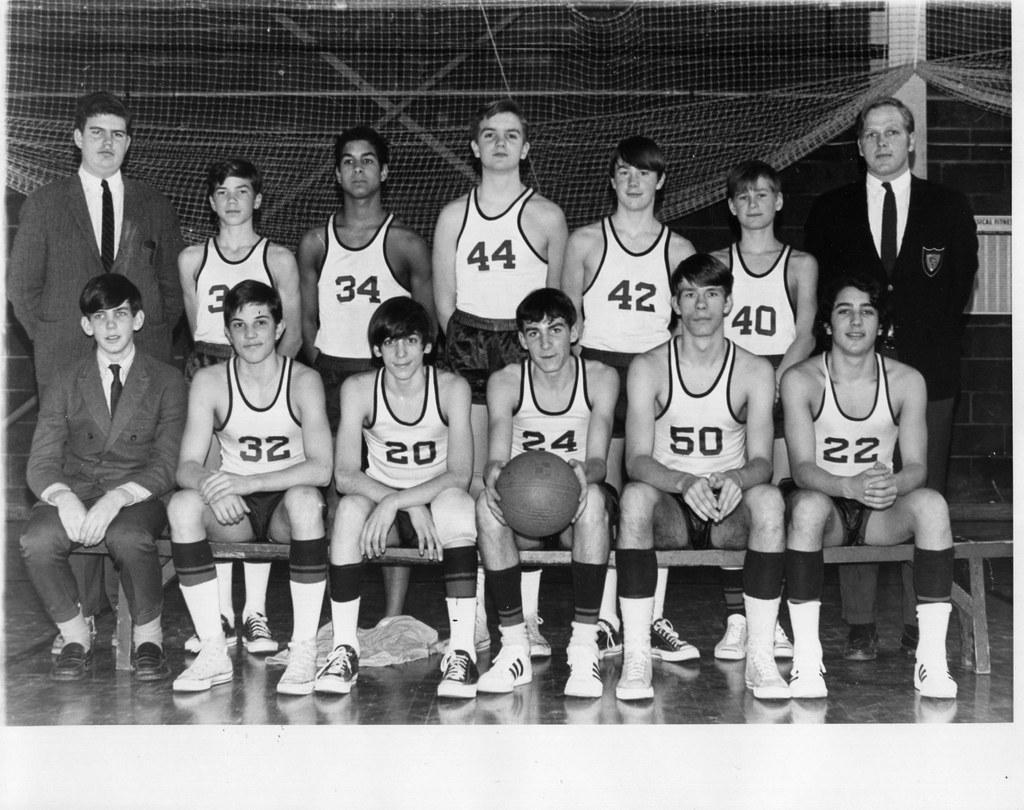How many people are in the image? There are many people in the image. What are the people wearing? The people are wearing jerseys. What is the boy in the front of the image holding? The boy is holding a ball in the front of the image. What is at the bottom of the image? There is a floor at the bottom of the image. What can be seen in the background of the image? There is a net visible in the background of the image. What shape is the zipper on the boy's jersey in the image? There is no zipper present on the boy's jersey in the image. 